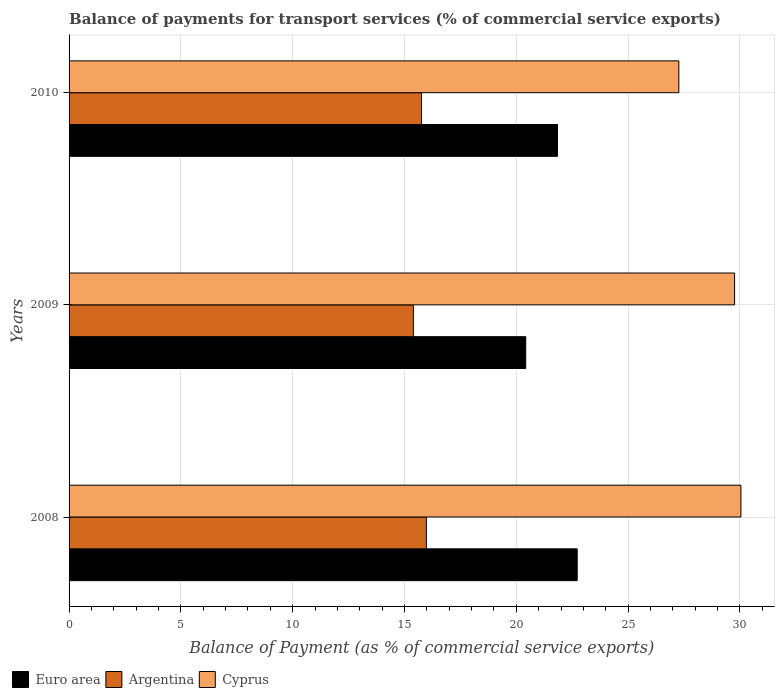How many different coloured bars are there?
Offer a very short reply. 3. How many bars are there on the 1st tick from the top?
Your answer should be compact. 3. What is the balance of payments for transport services in Cyprus in 2008?
Your answer should be compact. 30.05. Across all years, what is the maximum balance of payments for transport services in Cyprus?
Offer a terse response. 30.05. Across all years, what is the minimum balance of payments for transport services in Argentina?
Offer a very short reply. 15.4. What is the total balance of payments for transport services in Euro area in the graph?
Your response must be concise. 64.99. What is the difference between the balance of payments for transport services in Euro area in 2009 and that in 2010?
Offer a very short reply. -1.42. What is the difference between the balance of payments for transport services in Cyprus in 2010 and the balance of payments for transport services in Argentina in 2008?
Ensure brevity in your answer.  11.29. What is the average balance of payments for transport services in Euro area per year?
Give a very brief answer. 21.66. In the year 2009, what is the difference between the balance of payments for transport services in Argentina and balance of payments for transport services in Euro area?
Provide a succinct answer. -5.03. What is the ratio of the balance of payments for transport services in Cyprus in 2008 to that in 2009?
Offer a terse response. 1.01. Is the balance of payments for transport services in Euro area in 2008 less than that in 2009?
Ensure brevity in your answer.  No. What is the difference between the highest and the second highest balance of payments for transport services in Cyprus?
Your answer should be very brief. 0.28. What is the difference between the highest and the lowest balance of payments for transport services in Euro area?
Provide a succinct answer. 2.3. In how many years, is the balance of payments for transport services in Euro area greater than the average balance of payments for transport services in Euro area taken over all years?
Give a very brief answer. 2. What does the 1st bar from the top in 2009 represents?
Make the answer very short. Cyprus. Is it the case that in every year, the sum of the balance of payments for transport services in Cyprus and balance of payments for transport services in Argentina is greater than the balance of payments for transport services in Euro area?
Keep it short and to the point. Yes. What is the difference between two consecutive major ticks on the X-axis?
Your response must be concise. 5. Are the values on the major ticks of X-axis written in scientific E-notation?
Offer a very short reply. No. Does the graph contain grids?
Your response must be concise. Yes. What is the title of the graph?
Your response must be concise. Balance of payments for transport services (% of commercial service exports). What is the label or title of the X-axis?
Make the answer very short. Balance of Payment (as % of commercial service exports). What is the label or title of the Y-axis?
Offer a very short reply. Years. What is the Balance of Payment (as % of commercial service exports) of Euro area in 2008?
Your answer should be very brief. 22.73. What is the Balance of Payment (as % of commercial service exports) in Argentina in 2008?
Make the answer very short. 15.98. What is the Balance of Payment (as % of commercial service exports) of Cyprus in 2008?
Provide a succinct answer. 30.05. What is the Balance of Payment (as % of commercial service exports) in Euro area in 2009?
Ensure brevity in your answer.  20.42. What is the Balance of Payment (as % of commercial service exports) of Argentina in 2009?
Your answer should be compact. 15.4. What is the Balance of Payment (as % of commercial service exports) of Cyprus in 2009?
Your answer should be compact. 29.76. What is the Balance of Payment (as % of commercial service exports) of Euro area in 2010?
Keep it short and to the point. 21.84. What is the Balance of Payment (as % of commercial service exports) of Argentina in 2010?
Provide a succinct answer. 15.76. What is the Balance of Payment (as % of commercial service exports) of Cyprus in 2010?
Offer a very short reply. 27.27. Across all years, what is the maximum Balance of Payment (as % of commercial service exports) in Euro area?
Your response must be concise. 22.73. Across all years, what is the maximum Balance of Payment (as % of commercial service exports) of Argentina?
Your answer should be very brief. 15.98. Across all years, what is the maximum Balance of Payment (as % of commercial service exports) in Cyprus?
Ensure brevity in your answer.  30.05. Across all years, what is the minimum Balance of Payment (as % of commercial service exports) of Euro area?
Ensure brevity in your answer.  20.42. Across all years, what is the minimum Balance of Payment (as % of commercial service exports) of Argentina?
Your answer should be very brief. 15.4. Across all years, what is the minimum Balance of Payment (as % of commercial service exports) of Cyprus?
Ensure brevity in your answer.  27.27. What is the total Balance of Payment (as % of commercial service exports) of Euro area in the graph?
Give a very brief answer. 64.99. What is the total Balance of Payment (as % of commercial service exports) of Argentina in the graph?
Ensure brevity in your answer.  47.14. What is the total Balance of Payment (as % of commercial service exports) of Cyprus in the graph?
Offer a very short reply. 87.08. What is the difference between the Balance of Payment (as % of commercial service exports) in Euro area in 2008 and that in 2009?
Your response must be concise. 2.3. What is the difference between the Balance of Payment (as % of commercial service exports) of Argentina in 2008 and that in 2009?
Your response must be concise. 0.58. What is the difference between the Balance of Payment (as % of commercial service exports) in Cyprus in 2008 and that in 2009?
Your answer should be very brief. 0.28. What is the difference between the Balance of Payment (as % of commercial service exports) in Euro area in 2008 and that in 2010?
Your response must be concise. 0.88. What is the difference between the Balance of Payment (as % of commercial service exports) in Argentina in 2008 and that in 2010?
Your response must be concise. 0.22. What is the difference between the Balance of Payment (as % of commercial service exports) of Cyprus in 2008 and that in 2010?
Provide a short and direct response. 2.78. What is the difference between the Balance of Payment (as % of commercial service exports) of Euro area in 2009 and that in 2010?
Your answer should be compact. -1.42. What is the difference between the Balance of Payment (as % of commercial service exports) of Argentina in 2009 and that in 2010?
Offer a very short reply. -0.36. What is the difference between the Balance of Payment (as % of commercial service exports) of Cyprus in 2009 and that in 2010?
Your answer should be very brief. 2.49. What is the difference between the Balance of Payment (as % of commercial service exports) of Euro area in 2008 and the Balance of Payment (as % of commercial service exports) of Argentina in 2009?
Make the answer very short. 7.33. What is the difference between the Balance of Payment (as % of commercial service exports) in Euro area in 2008 and the Balance of Payment (as % of commercial service exports) in Cyprus in 2009?
Keep it short and to the point. -7.04. What is the difference between the Balance of Payment (as % of commercial service exports) in Argentina in 2008 and the Balance of Payment (as % of commercial service exports) in Cyprus in 2009?
Ensure brevity in your answer.  -13.78. What is the difference between the Balance of Payment (as % of commercial service exports) of Euro area in 2008 and the Balance of Payment (as % of commercial service exports) of Argentina in 2010?
Offer a very short reply. 6.96. What is the difference between the Balance of Payment (as % of commercial service exports) of Euro area in 2008 and the Balance of Payment (as % of commercial service exports) of Cyprus in 2010?
Your answer should be compact. -4.54. What is the difference between the Balance of Payment (as % of commercial service exports) of Argentina in 2008 and the Balance of Payment (as % of commercial service exports) of Cyprus in 2010?
Provide a short and direct response. -11.29. What is the difference between the Balance of Payment (as % of commercial service exports) in Euro area in 2009 and the Balance of Payment (as % of commercial service exports) in Argentina in 2010?
Give a very brief answer. 4.66. What is the difference between the Balance of Payment (as % of commercial service exports) of Euro area in 2009 and the Balance of Payment (as % of commercial service exports) of Cyprus in 2010?
Your response must be concise. -6.85. What is the difference between the Balance of Payment (as % of commercial service exports) of Argentina in 2009 and the Balance of Payment (as % of commercial service exports) of Cyprus in 2010?
Provide a short and direct response. -11.87. What is the average Balance of Payment (as % of commercial service exports) of Euro area per year?
Ensure brevity in your answer.  21.66. What is the average Balance of Payment (as % of commercial service exports) in Argentina per year?
Your answer should be compact. 15.71. What is the average Balance of Payment (as % of commercial service exports) of Cyprus per year?
Your answer should be very brief. 29.03. In the year 2008, what is the difference between the Balance of Payment (as % of commercial service exports) of Euro area and Balance of Payment (as % of commercial service exports) of Argentina?
Provide a short and direct response. 6.75. In the year 2008, what is the difference between the Balance of Payment (as % of commercial service exports) of Euro area and Balance of Payment (as % of commercial service exports) of Cyprus?
Your response must be concise. -7.32. In the year 2008, what is the difference between the Balance of Payment (as % of commercial service exports) in Argentina and Balance of Payment (as % of commercial service exports) in Cyprus?
Make the answer very short. -14.07. In the year 2009, what is the difference between the Balance of Payment (as % of commercial service exports) in Euro area and Balance of Payment (as % of commercial service exports) in Argentina?
Your answer should be compact. 5.03. In the year 2009, what is the difference between the Balance of Payment (as % of commercial service exports) of Euro area and Balance of Payment (as % of commercial service exports) of Cyprus?
Offer a very short reply. -9.34. In the year 2009, what is the difference between the Balance of Payment (as % of commercial service exports) in Argentina and Balance of Payment (as % of commercial service exports) in Cyprus?
Keep it short and to the point. -14.36. In the year 2010, what is the difference between the Balance of Payment (as % of commercial service exports) of Euro area and Balance of Payment (as % of commercial service exports) of Argentina?
Your answer should be very brief. 6.08. In the year 2010, what is the difference between the Balance of Payment (as % of commercial service exports) in Euro area and Balance of Payment (as % of commercial service exports) in Cyprus?
Keep it short and to the point. -5.43. In the year 2010, what is the difference between the Balance of Payment (as % of commercial service exports) in Argentina and Balance of Payment (as % of commercial service exports) in Cyprus?
Offer a very short reply. -11.51. What is the ratio of the Balance of Payment (as % of commercial service exports) of Euro area in 2008 to that in 2009?
Make the answer very short. 1.11. What is the ratio of the Balance of Payment (as % of commercial service exports) of Argentina in 2008 to that in 2009?
Your response must be concise. 1.04. What is the ratio of the Balance of Payment (as % of commercial service exports) of Cyprus in 2008 to that in 2009?
Make the answer very short. 1.01. What is the ratio of the Balance of Payment (as % of commercial service exports) in Euro area in 2008 to that in 2010?
Give a very brief answer. 1.04. What is the ratio of the Balance of Payment (as % of commercial service exports) in Argentina in 2008 to that in 2010?
Your response must be concise. 1.01. What is the ratio of the Balance of Payment (as % of commercial service exports) in Cyprus in 2008 to that in 2010?
Offer a very short reply. 1.1. What is the ratio of the Balance of Payment (as % of commercial service exports) in Euro area in 2009 to that in 2010?
Your response must be concise. 0.94. What is the ratio of the Balance of Payment (as % of commercial service exports) of Cyprus in 2009 to that in 2010?
Give a very brief answer. 1.09. What is the difference between the highest and the second highest Balance of Payment (as % of commercial service exports) of Euro area?
Give a very brief answer. 0.88. What is the difference between the highest and the second highest Balance of Payment (as % of commercial service exports) of Argentina?
Make the answer very short. 0.22. What is the difference between the highest and the second highest Balance of Payment (as % of commercial service exports) of Cyprus?
Ensure brevity in your answer.  0.28. What is the difference between the highest and the lowest Balance of Payment (as % of commercial service exports) of Euro area?
Provide a succinct answer. 2.3. What is the difference between the highest and the lowest Balance of Payment (as % of commercial service exports) in Argentina?
Keep it short and to the point. 0.58. What is the difference between the highest and the lowest Balance of Payment (as % of commercial service exports) in Cyprus?
Offer a terse response. 2.78. 